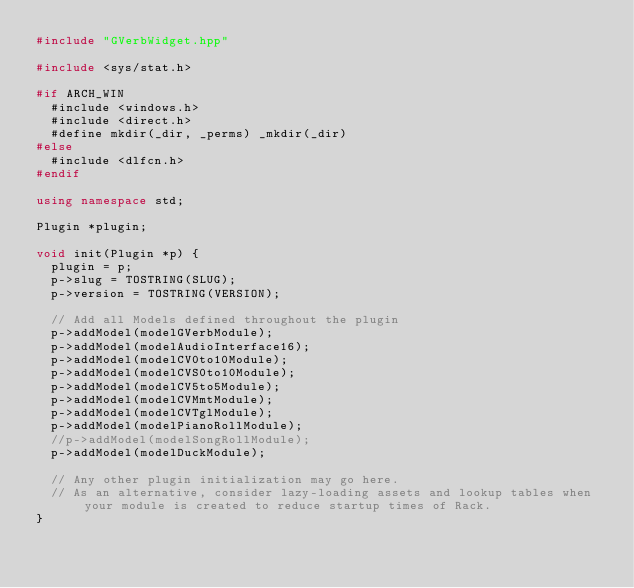Convert code to text. <code><loc_0><loc_0><loc_500><loc_500><_C++_>#include "GVerbWidget.hpp"

#include <sys/stat.h>

#if ARCH_WIN
	#include <windows.h>
	#include <direct.h>
	#define mkdir(_dir, _perms) _mkdir(_dir)
#else
	#include <dlfcn.h>
#endif

using namespace std;

Plugin *plugin;

void init(Plugin *p) {
	plugin = p;
	p->slug = TOSTRING(SLUG);
	p->version = TOSTRING(VERSION);

	// Add all Models defined throughout the plugin
	p->addModel(modelGVerbModule);
	p->addModel(modelAudioInterface16);
	p->addModel(modelCV0to10Module);
	p->addModel(modelCVS0to10Module);
	p->addModel(modelCV5to5Module);
	p->addModel(modelCVMmtModule);
	p->addModel(modelCVTglModule);
	p->addModel(modelPianoRollModule);
	//p->addModel(modelSongRollModule);
	p->addModel(modelDuckModule);

	// Any other plugin initialization may go here.
	// As an alternative, consider lazy-loading assets and lookup tables when your module is created to reduce startup times of Rack.
}
</code> 